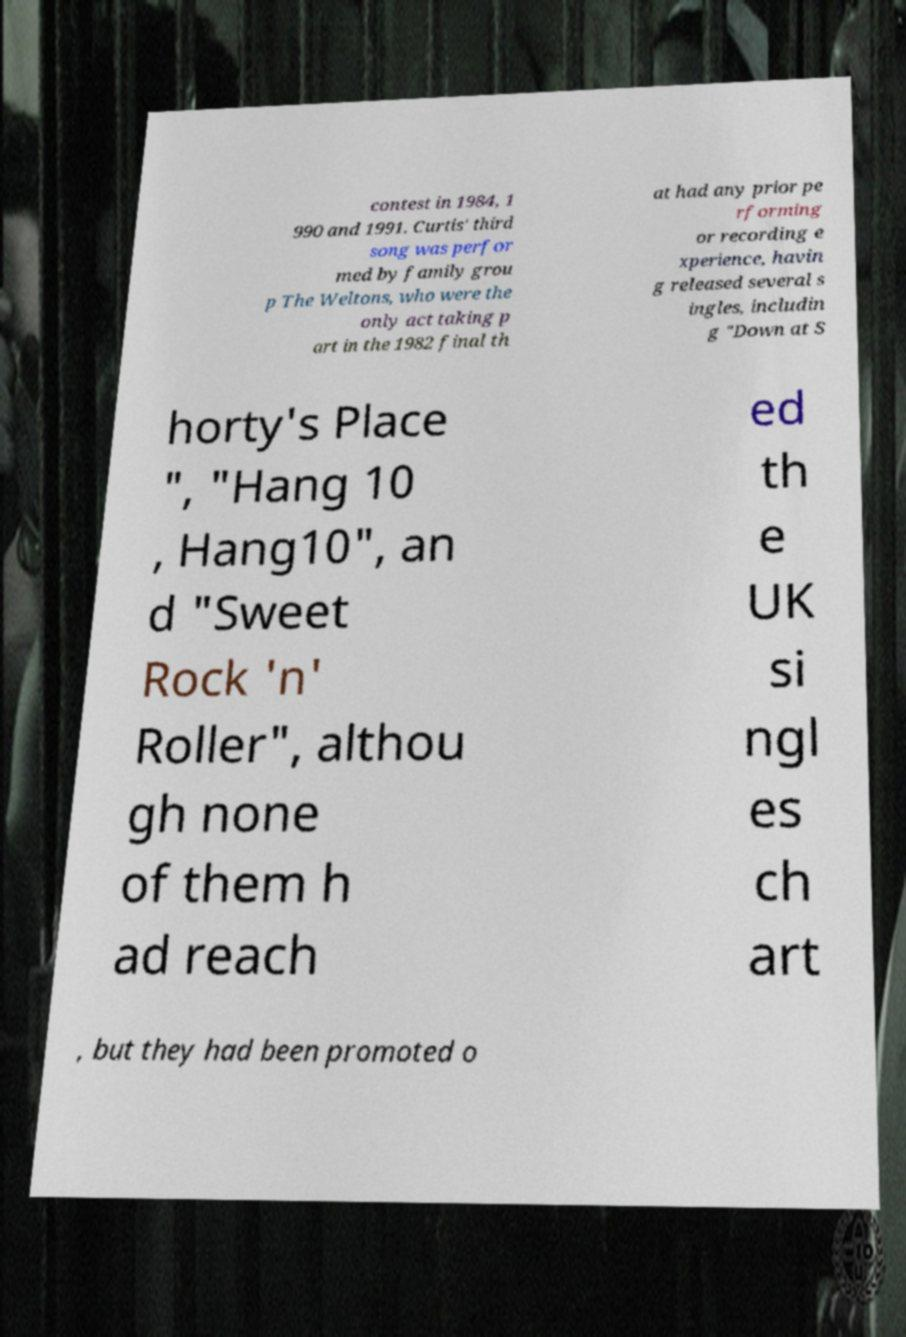For documentation purposes, I need the text within this image transcribed. Could you provide that? contest in 1984, 1 990 and 1991. Curtis' third song was perfor med by family grou p The Weltons, who were the only act taking p art in the 1982 final th at had any prior pe rforming or recording e xperience, havin g released several s ingles, includin g "Down at S horty's Place ", "Hang 10 , Hang10", an d "Sweet Rock 'n' Roller", althou gh none of them h ad reach ed th e UK si ngl es ch art , but they had been promoted o 